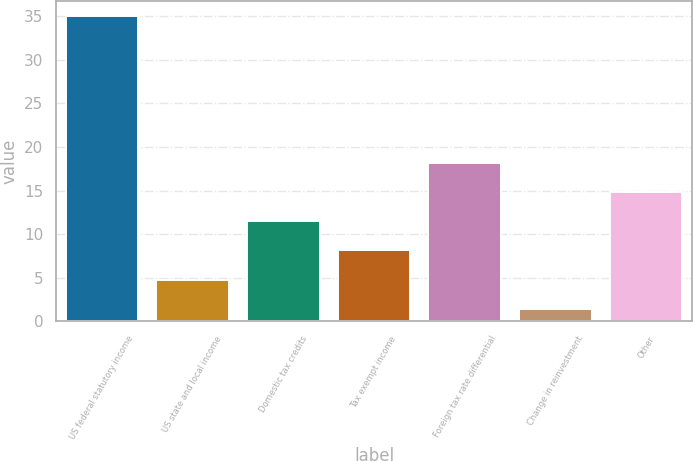<chart> <loc_0><loc_0><loc_500><loc_500><bar_chart><fcel>US federal statutory income<fcel>US state and local income<fcel>Domestic tax credits<fcel>Tax exempt income<fcel>Foreign tax rate differential<fcel>Change in reinvestment<fcel>Other<nl><fcel>35<fcel>4.76<fcel>11.48<fcel>8.12<fcel>18.2<fcel>1.4<fcel>14.84<nl></chart> 